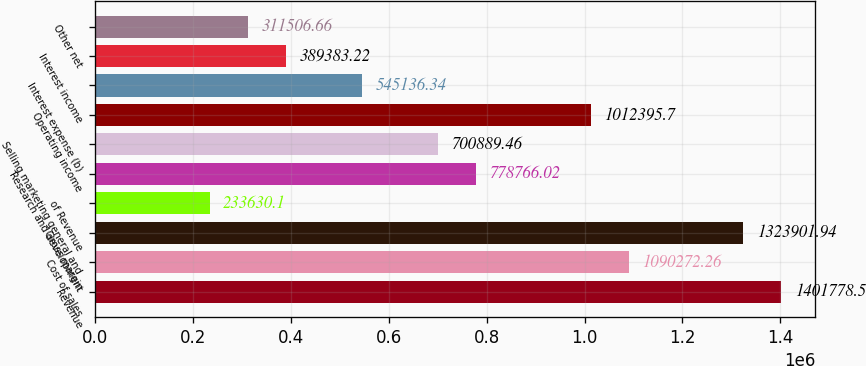<chart> <loc_0><loc_0><loc_500><loc_500><bar_chart><fcel>Revenue<fcel>Cost of sales<fcel>Gross margin<fcel>of Revenue<fcel>Research and development<fcel>Selling marketing general and<fcel>Operating income<fcel>Interest expense (b)<fcel>Interest income<fcel>Other net<nl><fcel>1.40178e+06<fcel>1.09027e+06<fcel>1.3239e+06<fcel>233630<fcel>778766<fcel>700889<fcel>1.0124e+06<fcel>545136<fcel>389383<fcel>311507<nl></chart> 